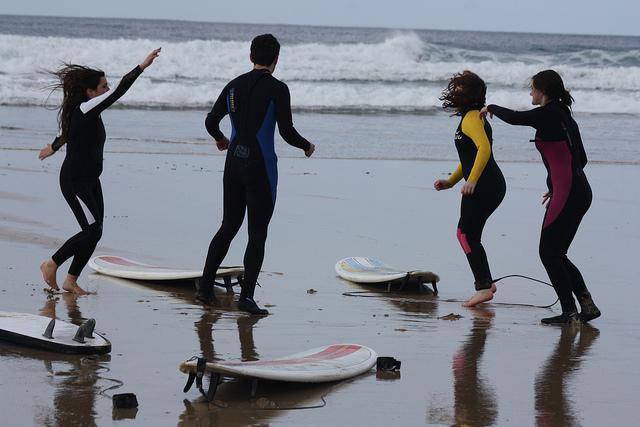How many surfboards can be seen?
Give a very brief answer. 4. How many people are visible?
Give a very brief answer. 4. How many ski poles are there?
Give a very brief answer. 0. 